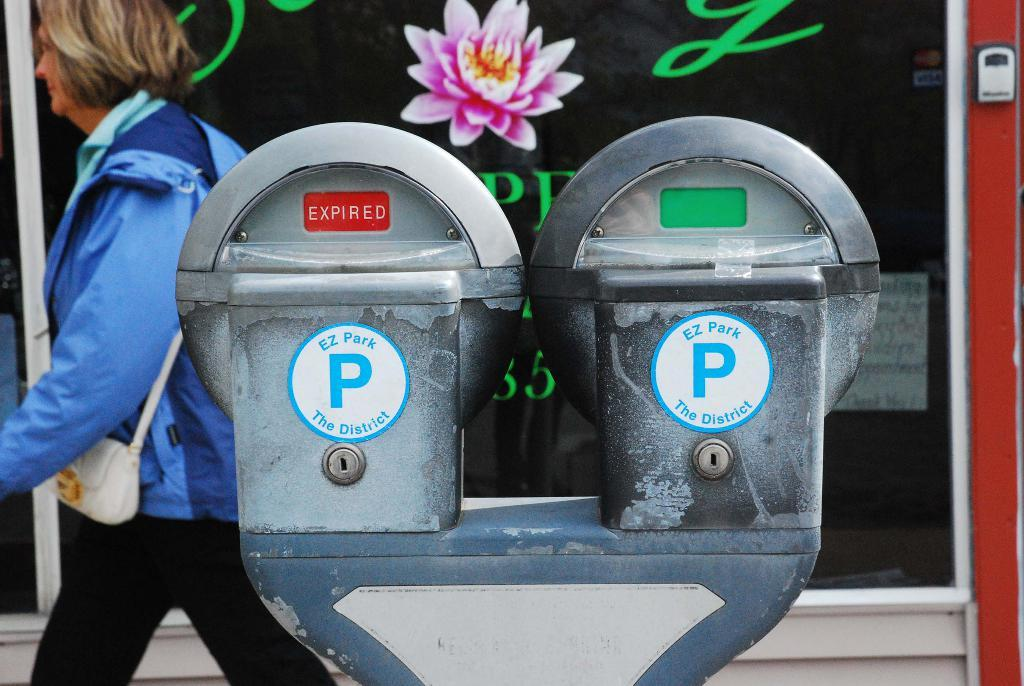<image>
Offer a succinct explanation of the picture presented. A woman in a blue jacket walks behind an expired parking meter. 